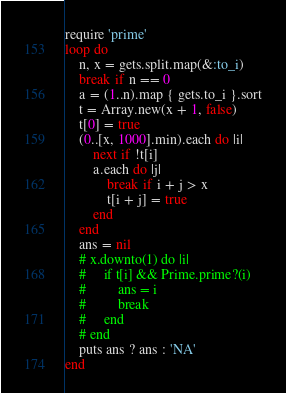<code> <loc_0><loc_0><loc_500><loc_500><_Ruby_>require 'prime'
loop do
    n, x = gets.split.map(&:to_i)
    break if n == 0
    a = (1..n).map { gets.to_i }.sort
    t = Array.new(x + 1, false)
    t[0] = true
    (0..[x, 1000].min).each do |i|
        next if !t[i]
        a.each do |j|
            break if i + j > x
            t[i + j] = true
        end
    end
    ans = nil
    # x.downto(1) do |i|
    #     if t[i] && Prime.prime?(i)
    #         ans = i
    #         break
    #     end
    # end
    puts ans ? ans : 'NA'
end

</code> 